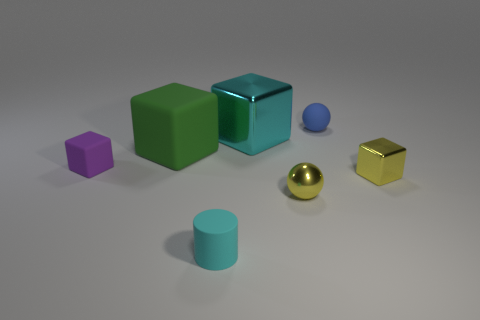What color is the small sphere that is made of the same material as the green object?
Your answer should be compact. Blue. What number of purple blocks have the same size as the blue rubber object?
Provide a succinct answer. 1. Is the big cube to the left of the tiny rubber cylinder made of the same material as the big cyan cube?
Give a very brief answer. No. Are there fewer yellow blocks that are left of the yellow metal cube than small cyan rubber spheres?
Provide a short and direct response. No. There is a cyan object that is in front of the yellow block; what is its shape?
Offer a terse response. Cylinder. What is the shape of the cyan rubber thing that is the same size as the metallic ball?
Provide a short and direct response. Cylinder. Is there a purple rubber object that has the same shape as the big green thing?
Give a very brief answer. Yes. There is a metallic object to the left of the small metallic sphere; is it the same shape as the big object that is on the left side of the cyan metallic block?
Your answer should be very brief. Yes. There is a yellow sphere that is the same size as the cyan matte thing; what is it made of?
Keep it short and to the point. Metal. What number of other things are there of the same material as the small yellow sphere
Give a very brief answer. 2. 